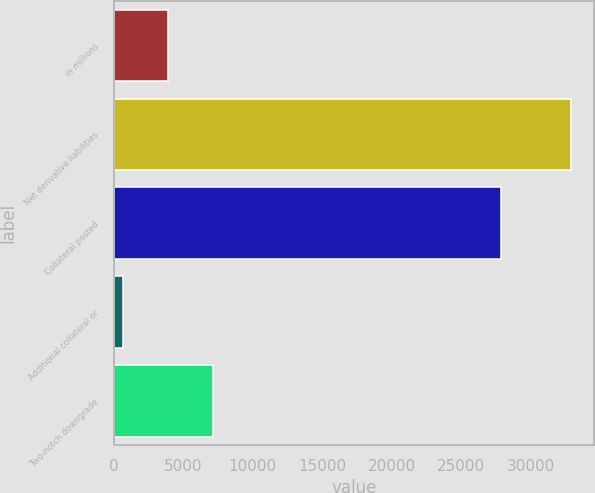Convert chart. <chart><loc_0><loc_0><loc_500><loc_500><bar_chart><fcel>in millions<fcel>Net derivative liabilities<fcel>Collateral posted<fcel>Additional collateral or<fcel>Two-notch downgrade<nl><fcel>3902<fcel>32927<fcel>27840<fcel>677<fcel>7127<nl></chart> 